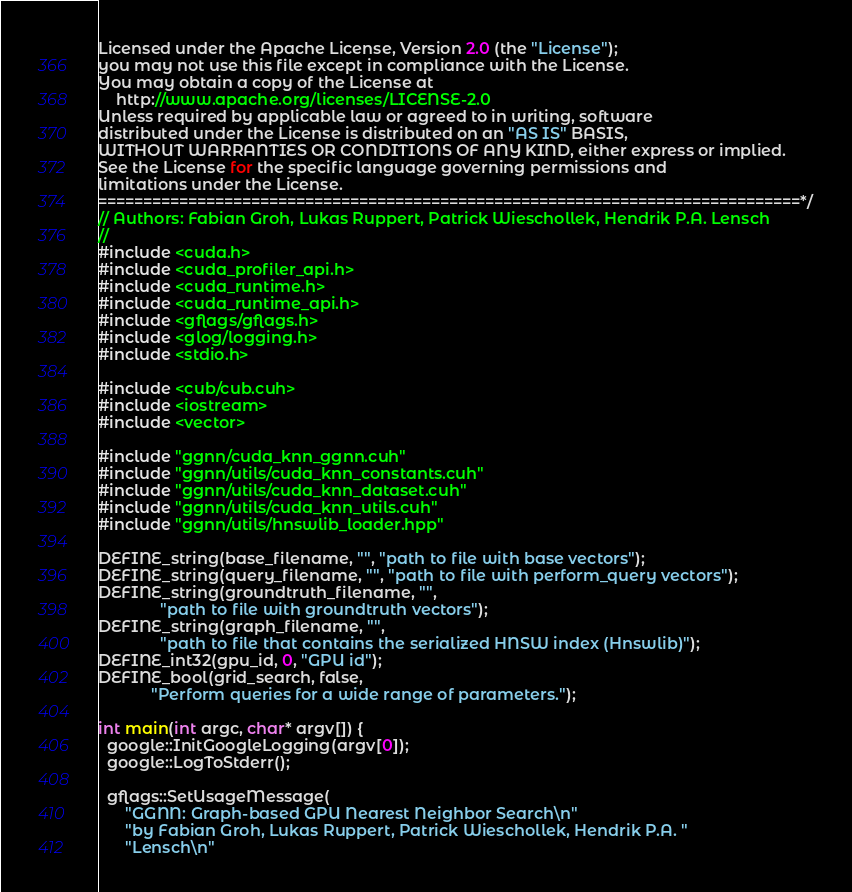<code> <loc_0><loc_0><loc_500><loc_500><_Cuda_>Licensed under the Apache License, Version 2.0 (the "License");
you may not use this file except in compliance with the License.
You may obtain a copy of the License at
    http://www.apache.org/licenses/LICENSE-2.0
Unless required by applicable law or agreed to in writing, software
distributed under the License is distributed on an "AS IS" BASIS,
WITHOUT WARRANTIES OR CONDITIONS OF ANY KIND, either express or implied.
See the License for the specific language governing permissions and
limitations under the License.
==============================================================================*/
// Authors: Fabian Groh, Lukas Ruppert, Patrick Wieschollek, Hendrik P.A. Lensch
//
#include <cuda.h>
#include <cuda_profiler_api.h>
#include <cuda_runtime.h>
#include <cuda_runtime_api.h>
#include <gflags/gflags.h>
#include <glog/logging.h>
#include <stdio.h>

#include <cub/cub.cuh>
#include <iostream>
#include <vector>

#include "ggnn/cuda_knn_ggnn.cuh"
#include "ggnn/utils/cuda_knn_constants.cuh"
#include "ggnn/utils/cuda_knn_dataset.cuh"
#include "ggnn/utils/cuda_knn_utils.cuh"
#include "ggnn/utils/hnswlib_loader.hpp"

DEFINE_string(base_filename, "", "path to file with base vectors");
DEFINE_string(query_filename, "", "path to file with perform_query vectors");
DEFINE_string(groundtruth_filename, "",
              "path to file with groundtruth vectors");
DEFINE_string(graph_filename, "",
              "path to file that contains the serialized HNSW index (Hnswlib)");
DEFINE_int32(gpu_id, 0, "GPU id");
DEFINE_bool(grid_search, false,
            "Perform queries for a wide range of parameters.");

int main(int argc, char* argv[]) {
  google::InitGoogleLogging(argv[0]);
  google::LogToStderr();

  gflags::SetUsageMessage(
      "GGNN: Graph-based GPU Nearest Neighbor Search\n"
      "by Fabian Groh, Lukas Ruppert, Patrick Wieschollek, Hendrik P.A. "
      "Lensch\n"</code> 